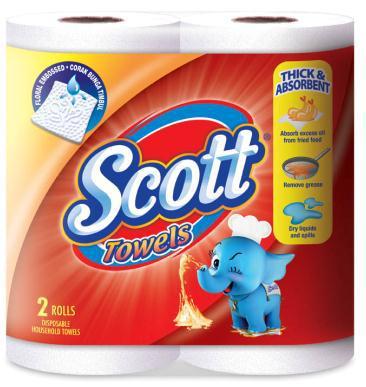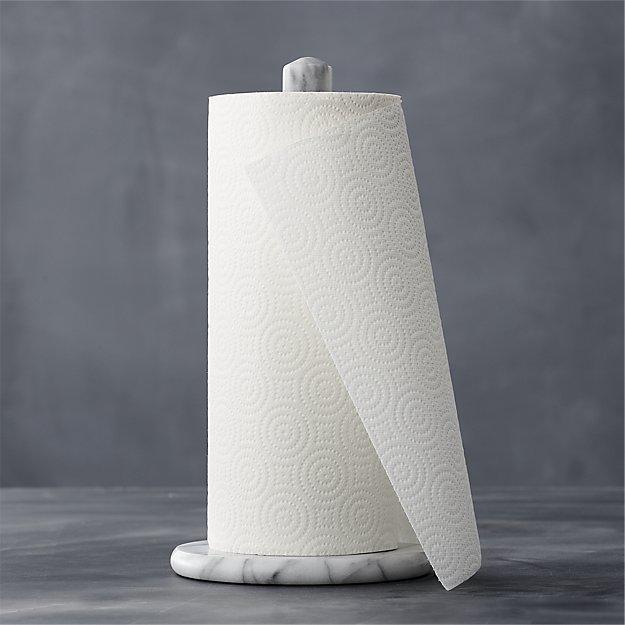The first image is the image on the left, the second image is the image on the right. Examine the images to the left and right. Is the description "One of the roll of paper towels is not in its wrapper." accurate? Answer yes or no. Yes. 